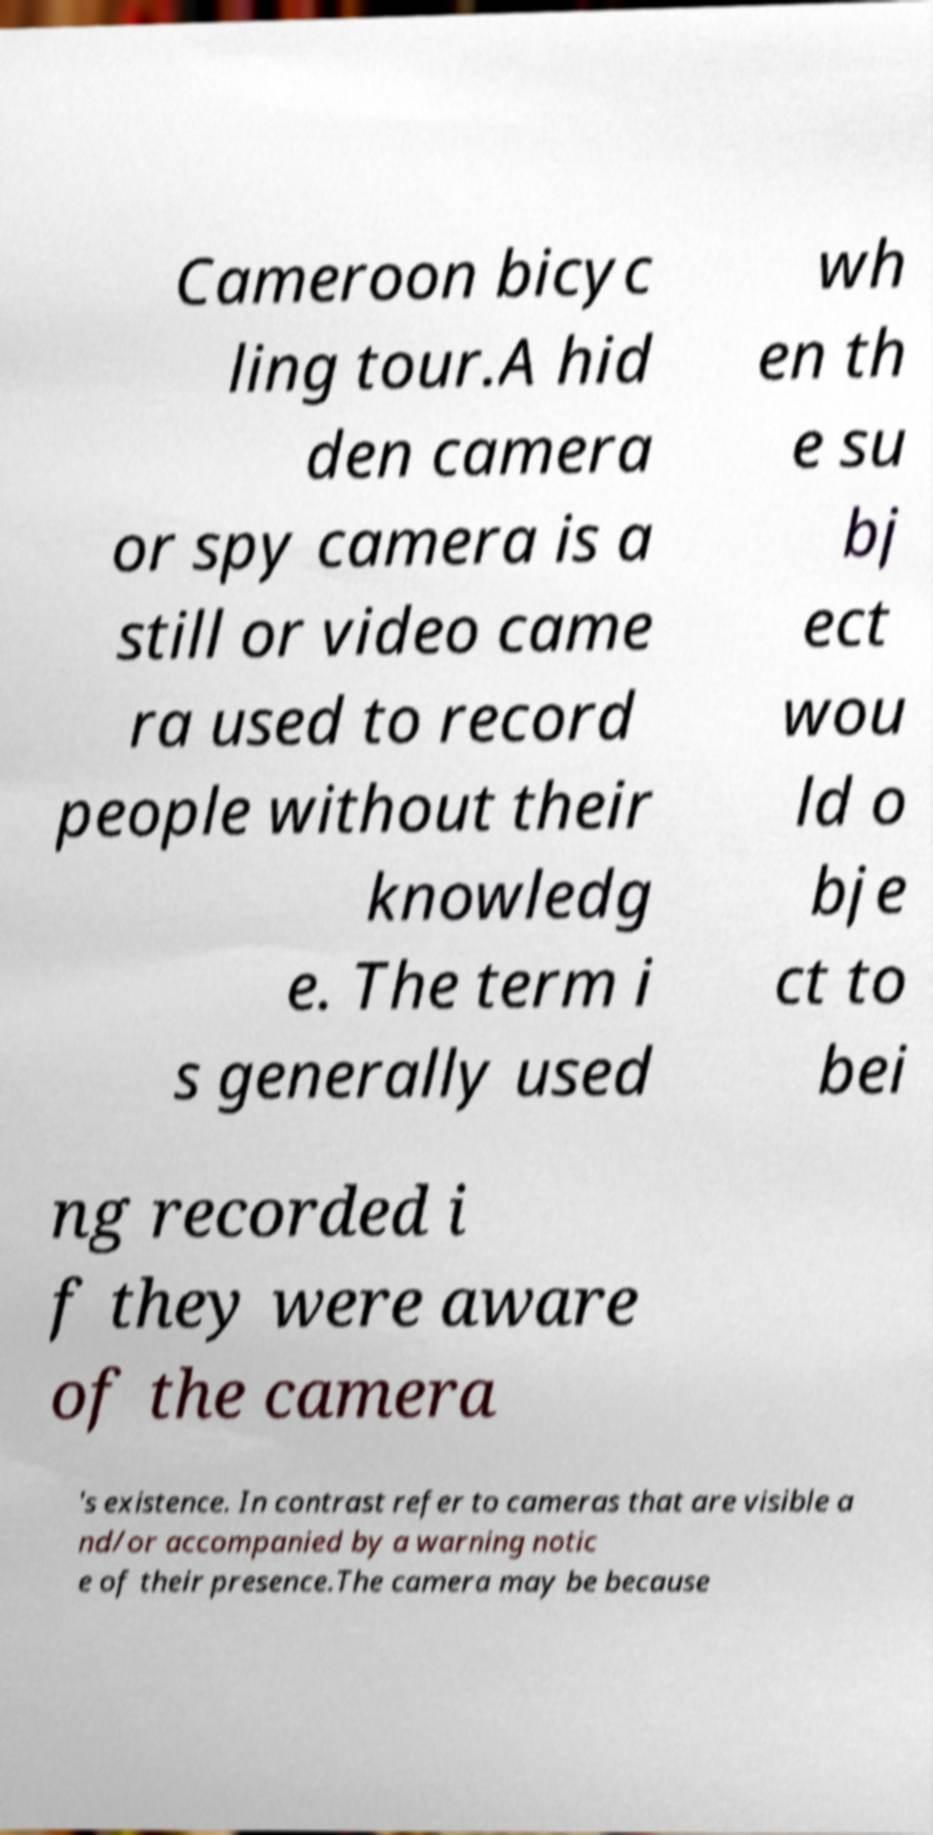There's text embedded in this image that I need extracted. Can you transcribe it verbatim? Cameroon bicyc ling tour.A hid den camera or spy camera is a still or video came ra used to record people without their knowledg e. The term i s generally used wh en th e su bj ect wou ld o bje ct to bei ng recorded i f they were aware of the camera 's existence. In contrast refer to cameras that are visible a nd/or accompanied by a warning notic e of their presence.The camera may be because 